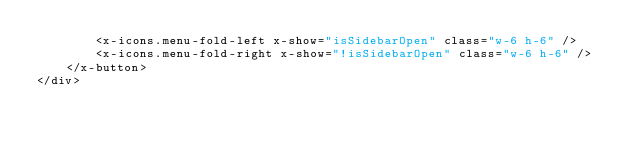<code> <loc_0><loc_0><loc_500><loc_500><_PHP_>        <x-icons.menu-fold-left x-show="isSidebarOpen" class="w-6 h-6" />
        <x-icons.menu-fold-right x-show="!isSidebarOpen" class="w-6 h-6" />
    </x-button>
</div></code> 